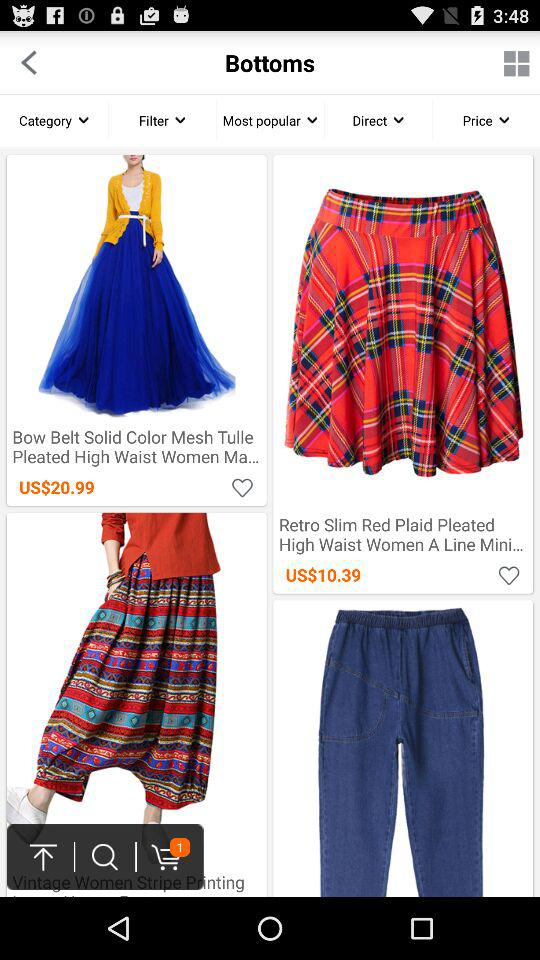How many items are in your shopping cart? There is 1 item in your shopping cart. 